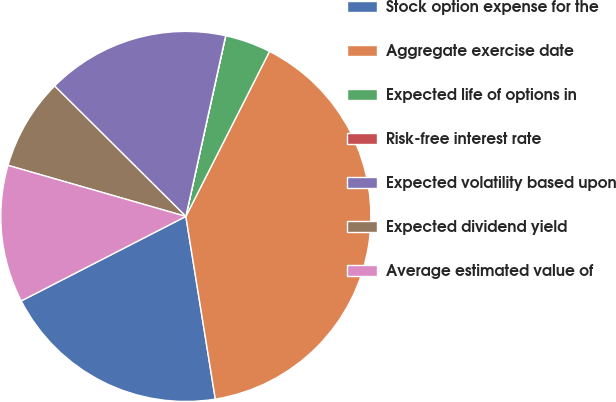Convert chart. <chart><loc_0><loc_0><loc_500><loc_500><pie_chart><fcel>Stock option expense for the<fcel>Aggregate exercise date<fcel>Expected life of options in<fcel>Risk-free interest rate<fcel>Expected volatility based upon<fcel>Expected dividend yield<fcel>Average estimated value of<nl><fcel>20.0%<fcel>39.99%<fcel>4.01%<fcel>0.01%<fcel>16.0%<fcel>8.0%<fcel>12.0%<nl></chart> 